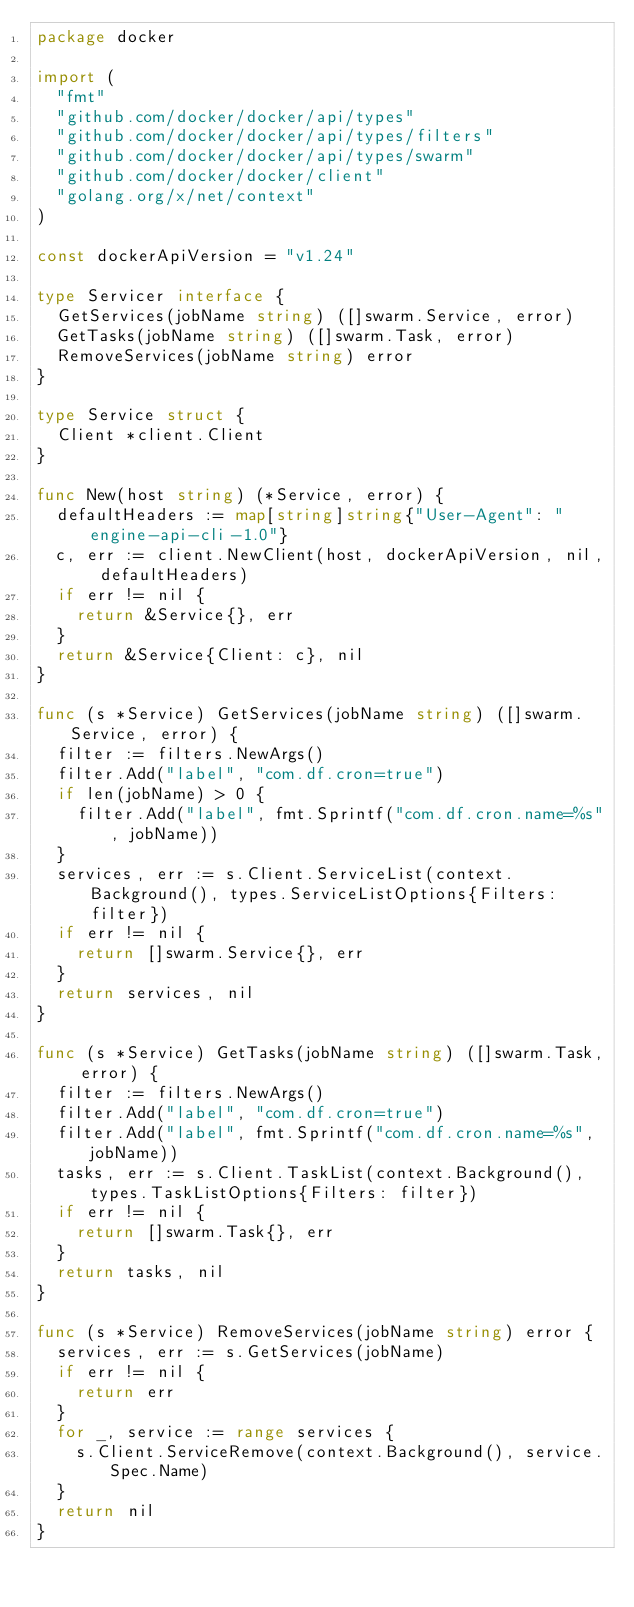Convert code to text. <code><loc_0><loc_0><loc_500><loc_500><_Go_>package docker

import (
	"fmt"
	"github.com/docker/docker/api/types"
	"github.com/docker/docker/api/types/filters"
	"github.com/docker/docker/api/types/swarm"
	"github.com/docker/docker/client"
	"golang.org/x/net/context"
)

const dockerApiVersion = "v1.24"

type Servicer interface {
	GetServices(jobName string) ([]swarm.Service, error)
	GetTasks(jobName string) ([]swarm.Task, error)
	RemoveServices(jobName string) error
}

type Service struct {
	Client *client.Client
}

func New(host string) (*Service, error) {
	defaultHeaders := map[string]string{"User-Agent": "engine-api-cli-1.0"}
	c, err := client.NewClient(host, dockerApiVersion, nil, defaultHeaders)
	if err != nil {
		return &Service{}, err
	}
	return &Service{Client: c}, nil
}

func (s *Service) GetServices(jobName string) ([]swarm.Service, error) {
	filter := filters.NewArgs()
	filter.Add("label", "com.df.cron=true")
	if len(jobName) > 0 {
		filter.Add("label", fmt.Sprintf("com.df.cron.name=%s", jobName))
	}
	services, err := s.Client.ServiceList(context.Background(), types.ServiceListOptions{Filters: filter})
	if err != nil {
		return []swarm.Service{}, err
	}
	return services, nil
}

func (s *Service) GetTasks(jobName string) ([]swarm.Task, error) {
	filter := filters.NewArgs()
	filter.Add("label", "com.df.cron=true")
	filter.Add("label", fmt.Sprintf("com.df.cron.name=%s", jobName))
	tasks, err := s.Client.TaskList(context.Background(), types.TaskListOptions{Filters: filter})
	if err != nil {
		return []swarm.Task{}, err
	}
	return tasks, nil
}

func (s *Service) RemoveServices(jobName string) error {
	services, err := s.GetServices(jobName)
	if err != nil {
		return err
	}
	for _, service := range services {
		s.Client.ServiceRemove(context.Background(), service.Spec.Name)
	}
	return nil
}
</code> 